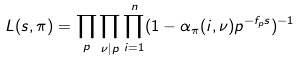Convert formula to latex. <formula><loc_0><loc_0><loc_500><loc_500>L ( s , \pi ) = \prod _ { p } \prod _ { \nu | p } \prod _ { i = 1 } ^ { n } ( 1 - \alpha _ { \pi } ( i , \nu ) p ^ { - f _ { p } s } ) ^ { - 1 }</formula> 